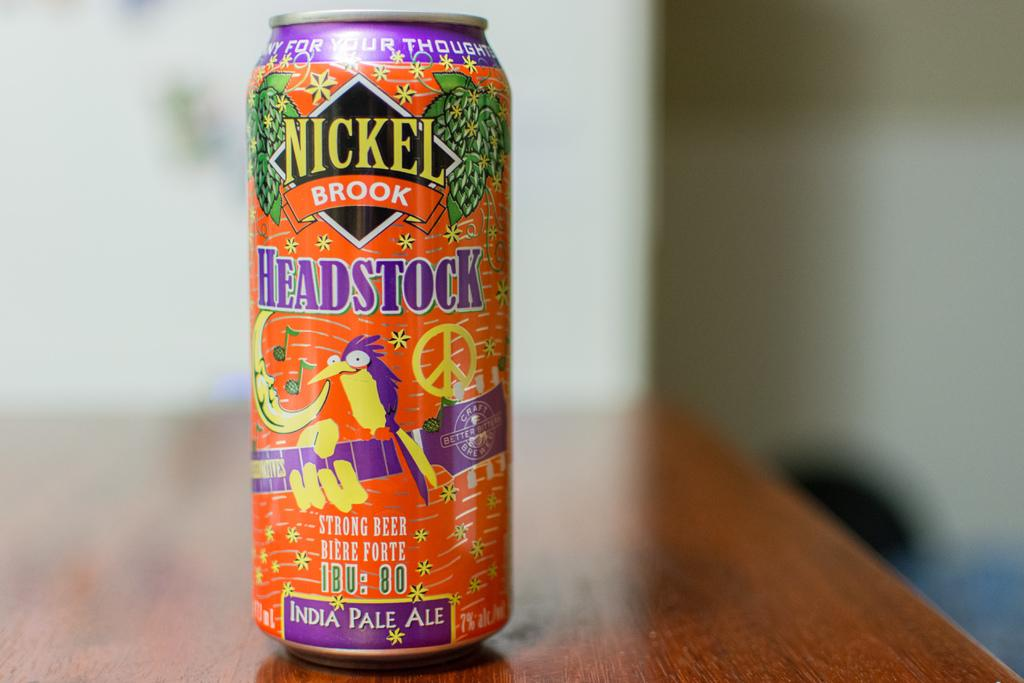<image>
Relay a brief, clear account of the picture shown. The vibrantly decorated can is Nickel Brook Headstock Strong Beer, an India Pale Ale. 